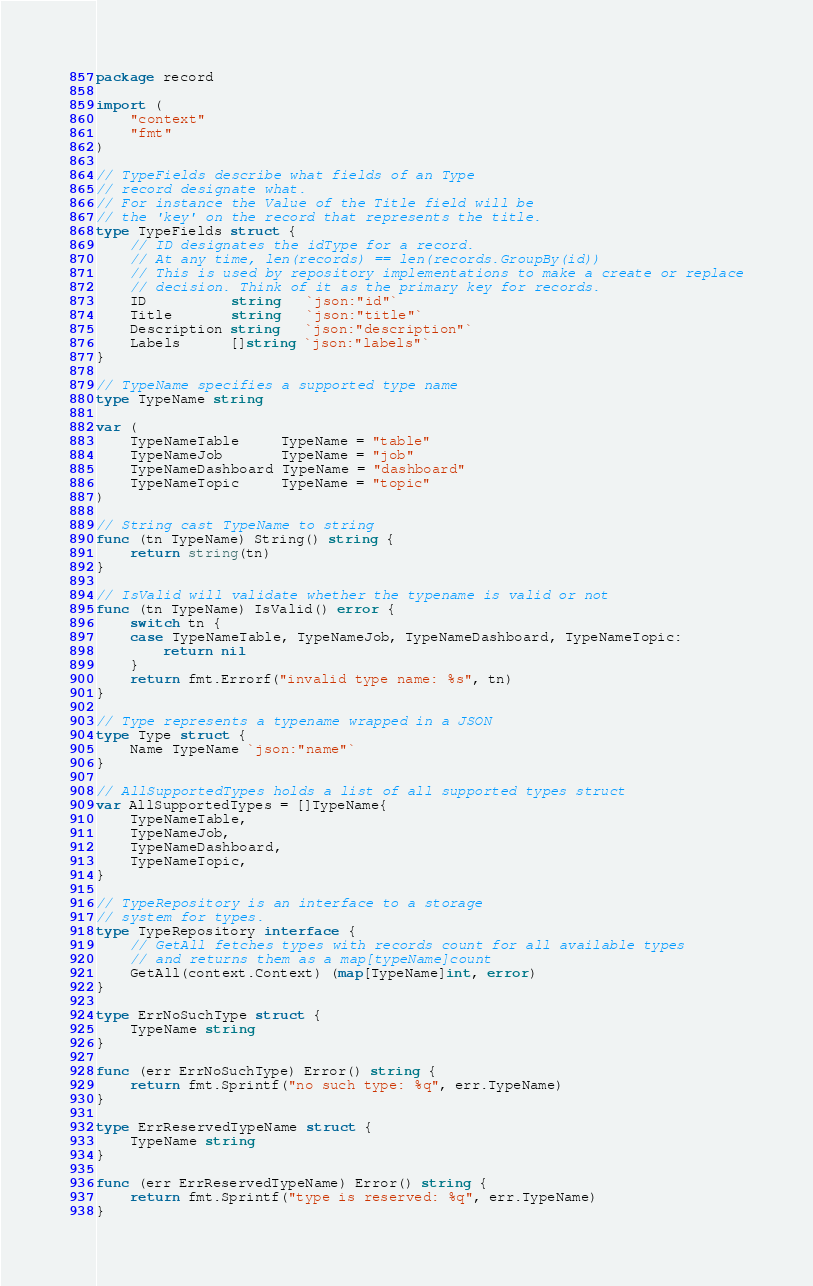Convert code to text. <code><loc_0><loc_0><loc_500><loc_500><_Go_>package record

import (
	"context"
	"fmt"
)

// TypeFields describe what fields of an Type
// record designate what.
// For instance the Value of the Title field will be
// the 'key' on the record that represents the title.
type TypeFields struct {
	// ID designates the idType for a record.
	// At any time, len(records) == len(records.GroupBy(id))
	// This is used by repository implementations to make a create or replace
	// decision. Think of it as the primary key for records.
	ID          string   `json:"id"`
	Title       string   `json:"title"`
	Description string   `json:"description"`
	Labels      []string `json:"labels"`
}

// TypeName specifies a supported type name
type TypeName string

var (
	TypeNameTable     TypeName = "table"
	TypeNameJob       TypeName = "job"
	TypeNameDashboard TypeName = "dashboard"
	TypeNameTopic     TypeName = "topic"
)

// String cast TypeName to string
func (tn TypeName) String() string {
	return string(tn)
}

// IsValid will validate whether the typename is valid or not
func (tn TypeName) IsValid() error {
	switch tn {
	case TypeNameTable, TypeNameJob, TypeNameDashboard, TypeNameTopic:
		return nil
	}
	return fmt.Errorf("invalid type name: %s", tn)
}

// Type represents a typename wrapped in a JSON
type Type struct {
	Name TypeName `json:"name"`
}

// AllSupportedTypes holds a list of all supported types struct
var AllSupportedTypes = []TypeName{
	TypeNameTable,
	TypeNameJob,
	TypeNameDashboard,
	TypeNameTopic,
}

// TypeRepository is an interface to a storage
// system for types.
type TypeRepository interface {
	// GetAll fetches types with records count for all available types
	// and returns them as a map[typeName]count
	GetAll(context.Context) (map[TypeName]int, error)
}

type ErrNoSuchType struct {
	TypeName string
}

func (err ErrNoSuchType) Error() string {
	return fmt.Sprintf("no such type: %q", err.TypeName)
}

type ErrReservedTypeName struct {
	TypeName string
}

func (err ErrReservedTypeName) Error() string {
	return fmt.Sprintf("type is reserved: %q", err.TypeName)
}
</code> 